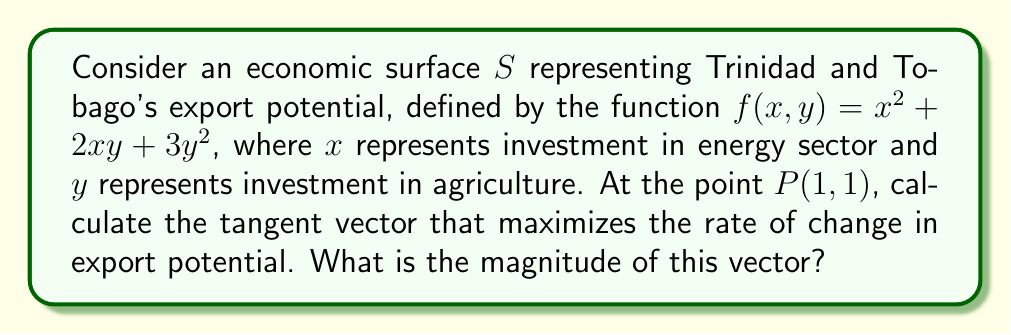Help me with this question. To solve this problem, we'll follow these steps:

1) First, we need to find the gradient of the function at point $P(1,1)$. The gradient vector is perpendicular to the level curves and points in the direction of steepest ascent.

   $\nabla f = (\frac{\partial f}{\partial x}, \frac{\partial f}{\partial y})$
   
   $\frac{\partial f}{\partial x} = 2x + 2y$
   $\frac{\partial f}{\partial y} = 2x + 6y$

   At point $P(1,1)$:
   $\nabla f(1,1) = (2(1) + 2(1), 2(1) + 6(1)) = (4, 8)$

2) The gradient vector $(4,8)$ gives the direction of steepest ascent, which maximizes the rate of change in export potential.

3) To find the magnitude of this vector, we use the Euclidean norm:

   $\|\nabla f(1,1)\| = \sqrt{4^2 + 8^2} = \sqrt{16 + 64} = \sqrt{80} = 4\sqrt{5}$

Therefore, the tangent vector that maximizes the rate of change in export potential at $P(1,1)$ is $(4,8)$, and its magnitude is $4\sqrt{5}$.
Answer: $4\sqrt{5}$ 